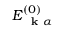Convert formula to latex. <formula><loc_0><loc_0><loc_500><loc_500>E _ { k \alpha } ^ { ( 0 ) }</formula> 